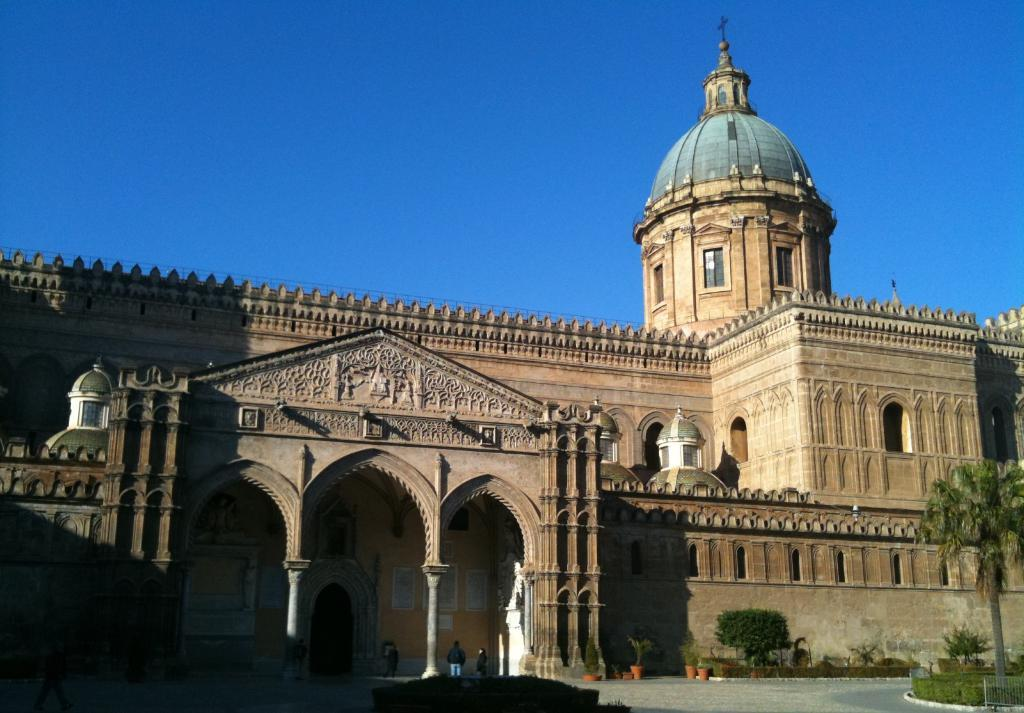What type of vegetation is at the bottom of the image? There is grass, trees, and houseplants at the bottom of the image. What type of barrier is present at the bottom of the image? There is a fence at the bottom of the image. What can be seen on the road in the image? There is a group of people on the road in the image. What is visible in the background of the image? There is a fort and the sky visible in the background of the image. Can you determine the time of day the image was taken? The image is likely taken during the day, as the sky is visible. How many trees are growing out of the heads of the people in the image? There are no trees growing out of the heads of the people in the image; this is not a realistic or accurate observation. 